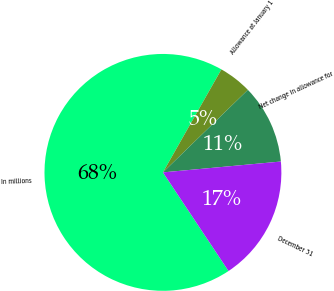Convert chart to OTSL. <chart><loc_0><loc_0><loc_500><loc_500><pie_chart><fcel>In millions<fcel>Allowance at January 1<fcel>Net change in allowance for<fcel>December 31<nl><fcel>67.56%<fcel>4.51%<fcel>10.81%<fcel>17.12%<nl></chart> 